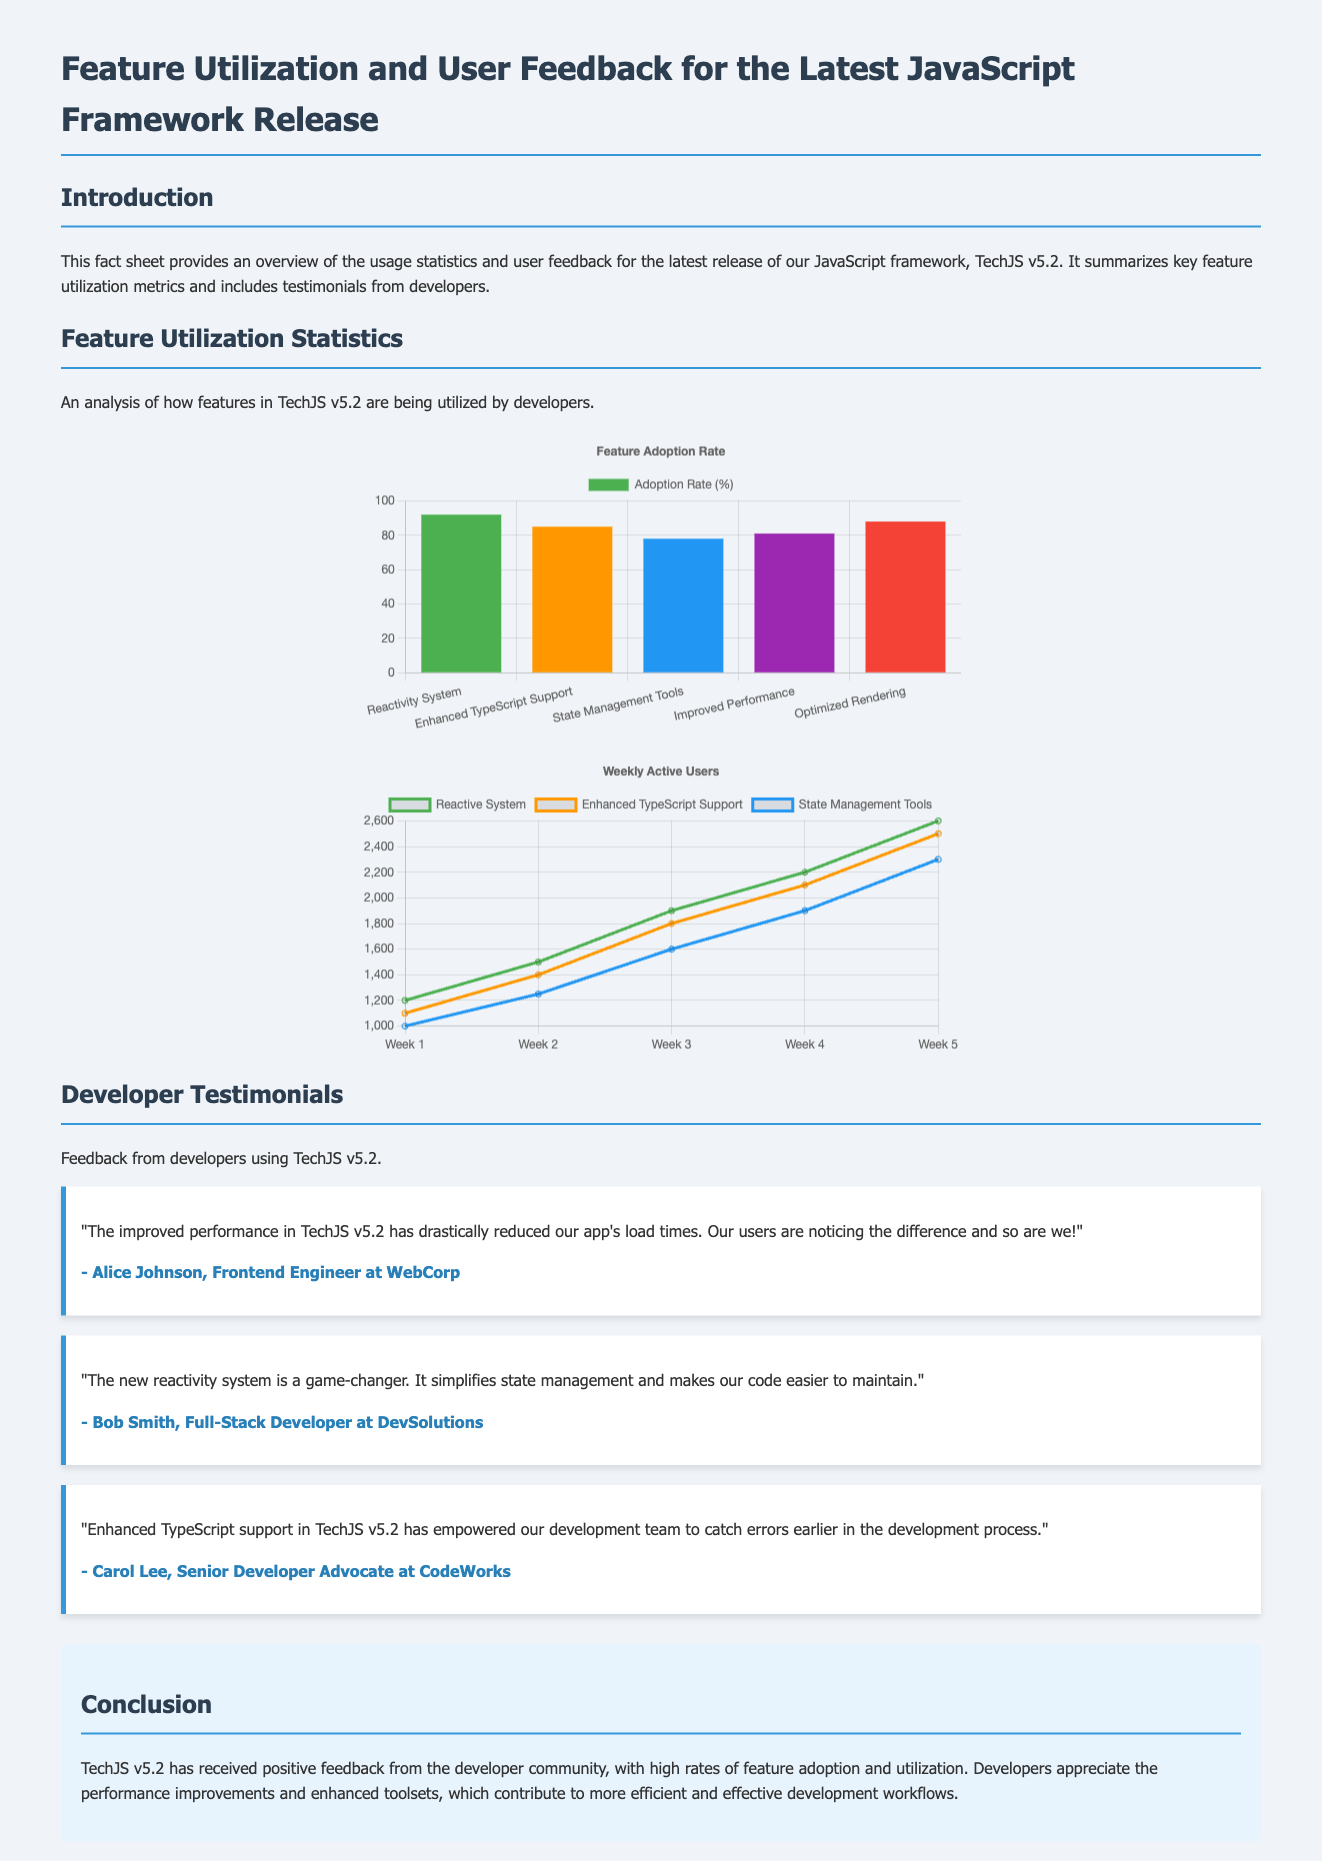What is the name of the framework discussed? The document provides information about the JavaScript framework called TechJS v5.2.
Answer: TechJS v5.2 What percentage of developers adopted the Reactivity System feature? The adoption rate of the Reactivity System feature is listed in the chart as 92%.
Answer: 92% Who is the author of the testimonial about performance improvements? The testimonial about improved performance is given by Alice Johnson, as stated in the document.
Answer: Alice Johnson What feature has the lowest adoption rate among those listed? According to the chart, the State Management Tools feature has the lowest adoption rate at 78%.
Answer: State Management Tools Which feature had the highest number of Weekly Active Users in Week 5? The Weekly Active Users chart indicates that the Enhanced TypeScript Support feature had the highest users in Week 5 with 2500 users.
Answer: 2500 What is the focus of the conclusion section? The conclusion summarizes the positive feedback and high rates of feature adoption and utilization for TechJS v5.2.
Answer: Positive feedback and high feature utilization Who provided feedback on the Enhanced TypeScript support? The developer who provided feedback on Enhanced TypeScript support is Carol Lee, as per the testimonials.
Answer: Carol Lee How many weeks are reflected in the Weekly Active Users chart? The Weekly Active Users chart includes data for five weeks.
Answer: Five weeks What type of chart is used for Feature Adoption Rate? The Feature Adoption Rate is represented using a bar chart, as specified in the script.
Answer: Bar chart 